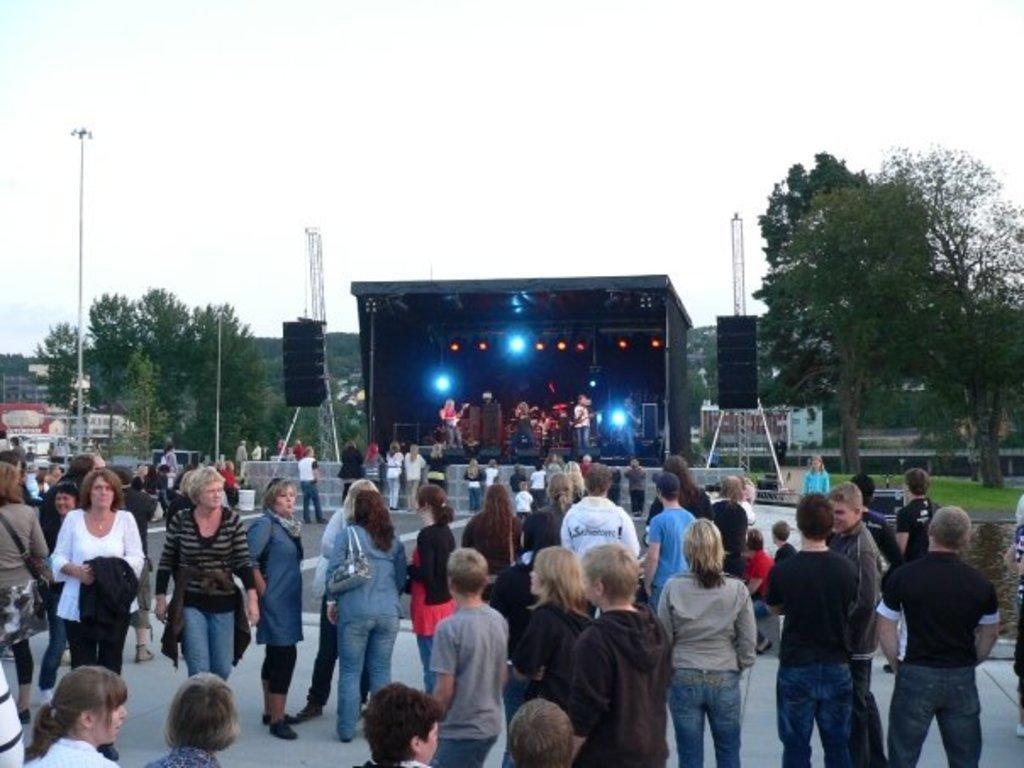Could you give a brief overview of what you see in this image? On the left side 2 women are walking, here many people are standing and observing at this. In the middle there is a stage, few people are performing the different actions. At the top it is the sky. 